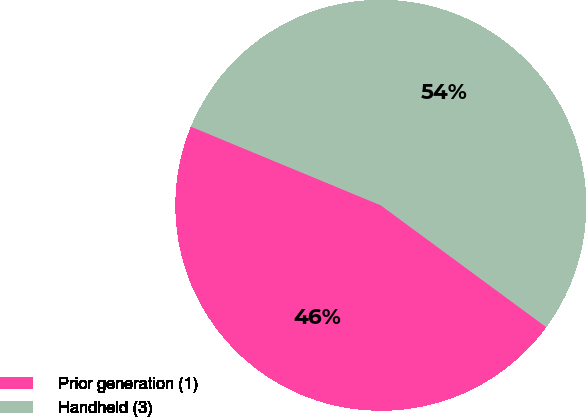<chart> <loc_0><loc_0><loc_500><loc_500><pie_chart><fcel>Prior generation (1)<fcel>Handheld (3)<nl><fcel>46.15%<fcel>53.85%<nl></chart> 